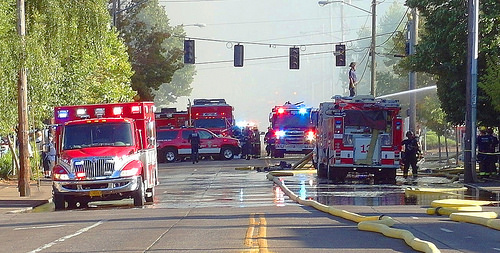<image>
Can you confirm if the man is to the left of the hose? Yes. From this viewpoint, the man is positioned to the left side relative to the hose. Is the firetruck next to the fireman? Yes. The firetruck is positioned adjacent to the fireman, located nearby in the same general area. Where is the man in relation to the firetruck? Is it next to the firetruck? No. The man is not positioned next to the firetruck. They are located in different areas of the scene. 